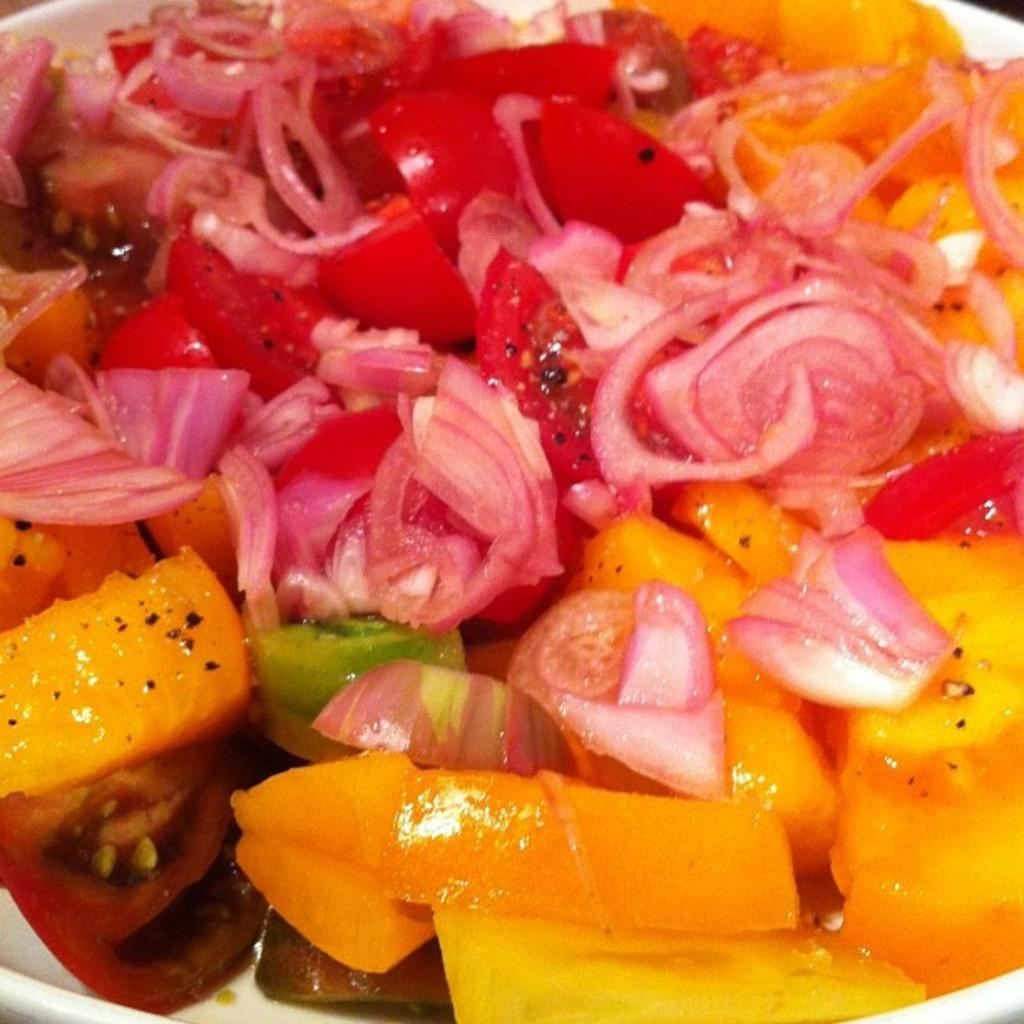What type of food can be seen on the plate in the image? There are onion pieces, tomato pieces, and other vegetable pieces on a plate. What color is the plate in the image? The plate is white in color. Can you describe the arrangement of the food on the plate? The food pieces are spread out on the plate, but the specific arrangement cannot be determined from the image. What type of cloth is draped over the question in the image? There is no cloth or question present in the image; it only features a plate with food pieces. 